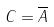<formula> <loc_0><loc_0><loc_500><loc_500>C = \overline { A }</formula> 